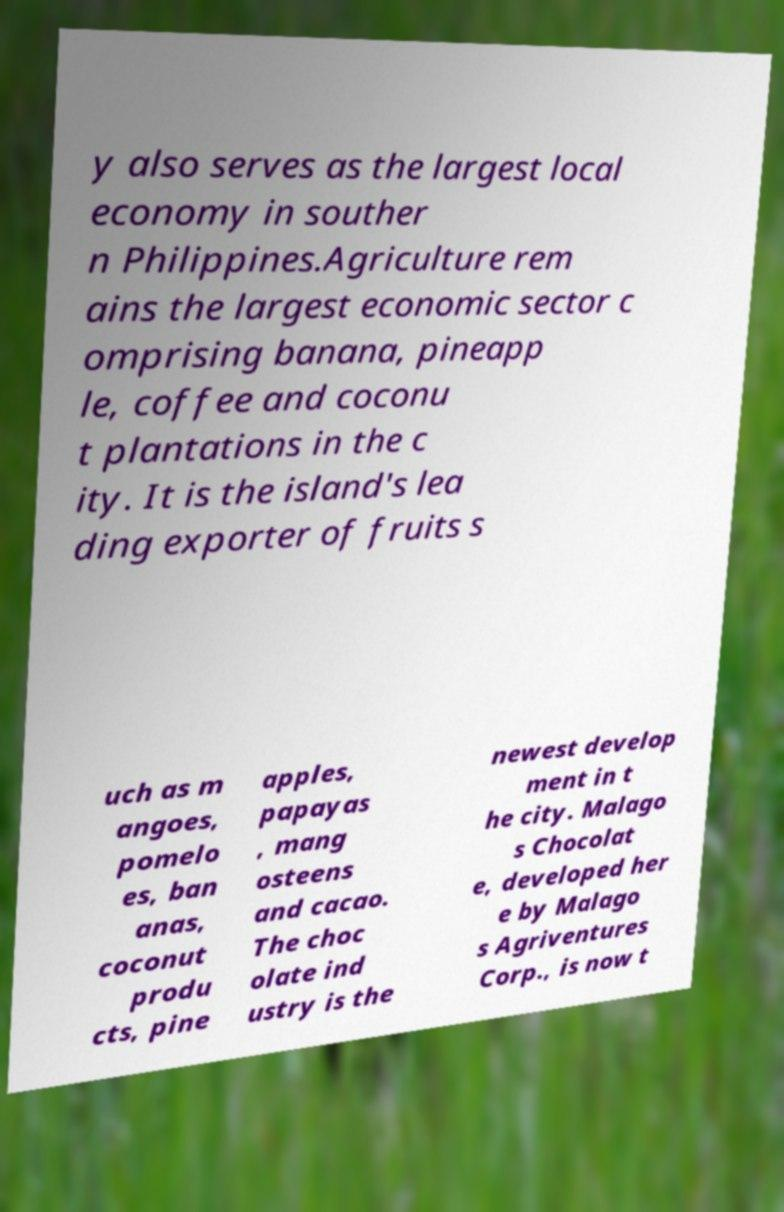Can you accurately transcribe the text from the provided image for me? y also serves as the largest local economy in souther n Philippines.Agriculture rem ains the largest economic sector c omprising banana, pineapp le, coffee and coconu t plantations in the c ity. It is the island's lea ding exporter of fruits s uch as m angoes, pomelo es, ban anas, coconut produ cts, pine apples, papayas , mang osteens and cacao. The choc olate ind ustry is the newest develop ment in t he city. Malago s Chocolat e, developed her e by Malago s Agriventures Corp., is now t 